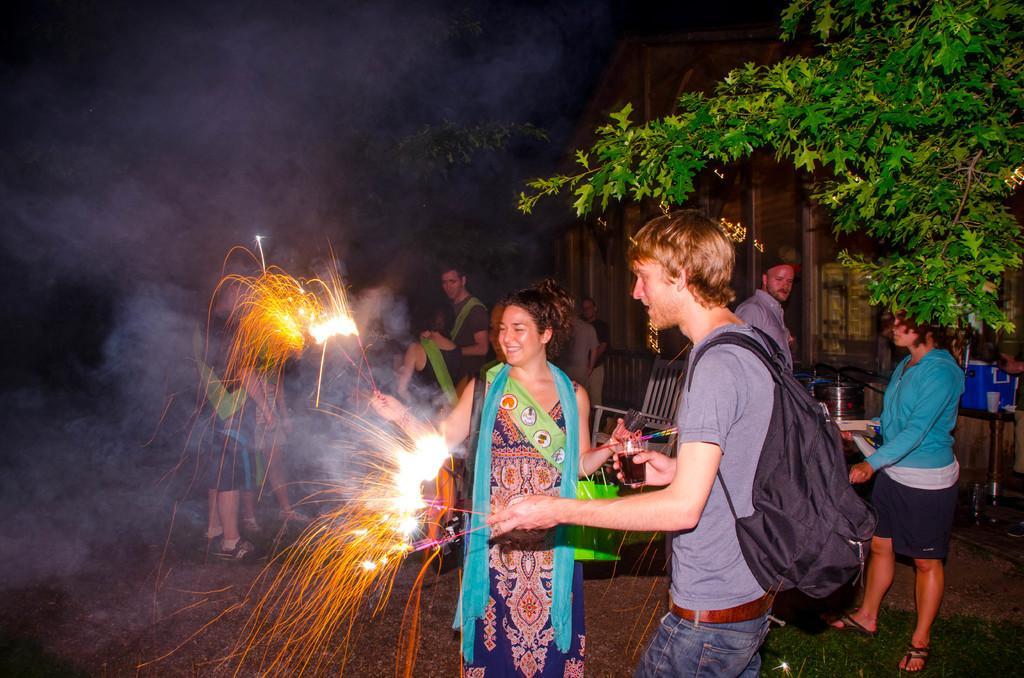How would you summarize this image in a sentence or two? In the image we can see there are people standing and wearing clothes. Here we can see fireworks and here we can see a man carrying a bag. We can see chair, grass, tree, building and the dark sky. 